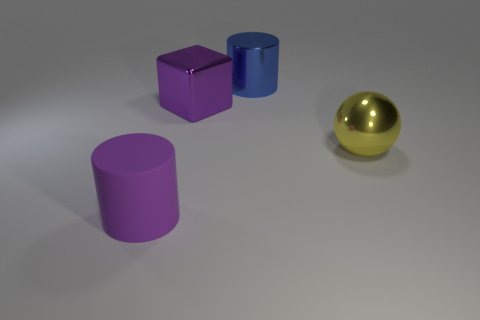Add 4 objects. How many objects exist? 8 Subtract all balls. How many objects are left? 3 Subtract 0 green cylinders. How many objects are left? 4 Subtract all blue matte things. Subtract all rubber objects. How many objects are left? 3 Add 4 large balls. How many large balls are left? 5 Add 1 purple matte things. How many purple matte things exist? 2 